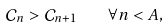<formula> <loc_0><loc_0><loc_500><loc_500>\mathcal { C } _ { n } > \mathcal { C } _ { n + 1 } \quad \forall n < A ,</formula> 